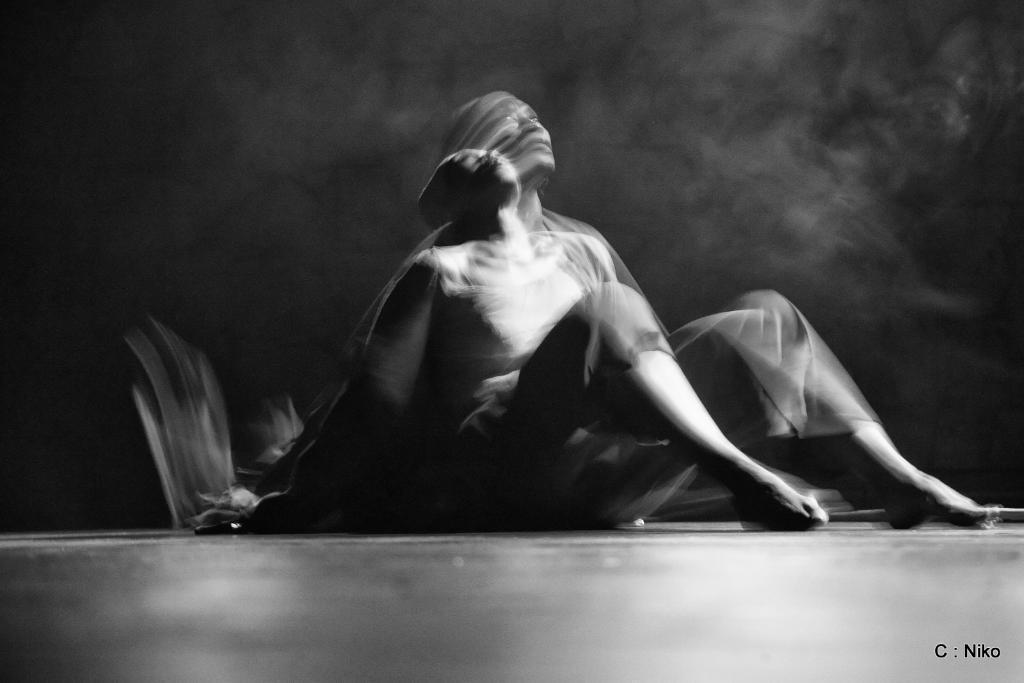Describe this image in one or two sentences. In this black and white picture there is a person sitting on the floor. At the bottom there is the floor. The background is dark. In the bottom right there is text on the image. The image is shaky. 